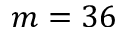<formula> <loc_0><loc_0><loc_500><loc_500>m = 3 6</formula> 